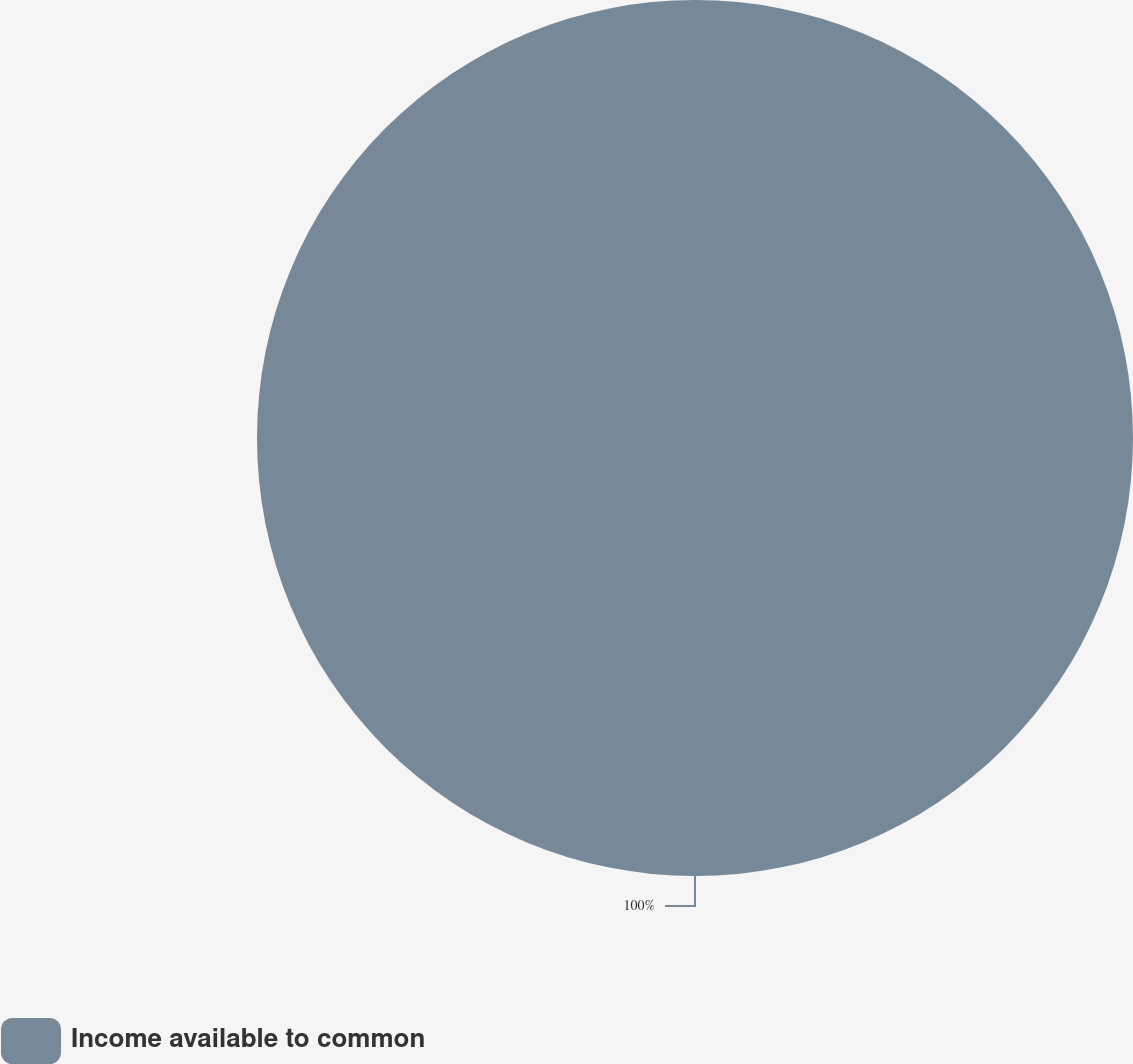Convert chart. <chart><loc_0><loc_0><loc_500><loc_500><pie_chart><fcel>Income available to common<nl><fcel>100.0%<nl></chart> 